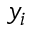Convert formula to latex. <formula><loc_0><loc_0><loc_500><loc_500>y _ { i }</formula> 